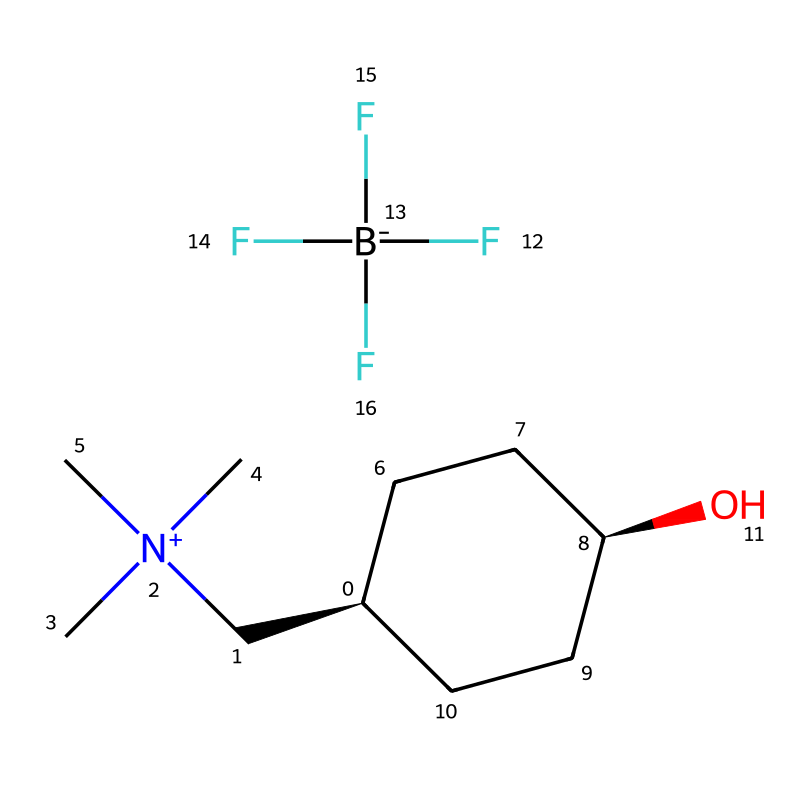What is the total number of carbon atoms in this ionic liquid? The SMILES representation indicates the presence of carbon atoms in the structural formula by counting the 'C' characters, which shows there are 9 carbon atoms in total.
Answer: nine How many nitrogen atoms are present in this ionic liquid? In the SMILES, the '[N+]' symbol indicates a positively charged nitrogen atom, and there is one such occurrence, meaning there is a total of one nitrogen atom.
Answer: one What functional group is indicated by the 'O' in the SMILES notation? The 'O' represents a hydroxyl group (-OH), which indicates the presence of alcohol functionality in the ionic liquid structure.
Answer: hydroxyl What charge does the nitrogen atom have in this compound? The '[N+]' notation indicates that the nitrogen atom carries a positive charge, which is typical for cations found in ionic liquids.
Answer: positive What type of salts are ionic liquids typically composed of? Ionic liquids are primarily composed of organic cations, like the one represented by 'C[N+](C)(C)C', and inorganic or organic anions, such as '[B-](F)(F)(F)', demonstrating they are salt forms.
Answer: salts What is the overall charge of this ionic liquid? The ionic liquid is neutral overall as it contains a positively charged nitrogen cation and a negatively charged boron anion, which balance each other out.
Answer: neutral Why might this ionic liquid be suitable for conductive inks? Ionic liquids generally have low volatility and can provide good ionic conductivity; the presence of functional groups and the unique cation and anion arrangement in this structure enhances these properties, making it suitable for conductive applications.
Answer: low volatility and good ionic conductivity 